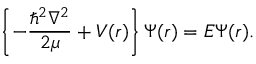<formula> <loc_0><loc_0><loc_500><loc_500>\left \{ - \frac { \hbar { ^ } { 2 } \nabla ^ { 2 } } { 2 \mu } + V ( r ) \right \} \Psi ( r ) = E \Psi ( r ) .</formula> 